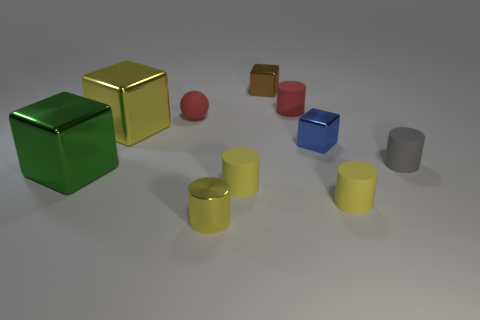The tiny rubber thing that is the same color as the rubber ball is what shape?
Offer a terse response. Cylinder. How big is the yellow thing left of the tiny red rubber object that is on the left side of the brown object?
Your answer should be very brief. Large. There is a small shiny cylinder; is it the same color as the matte cylinder to the left of the tiny brown thing?
Offer a very short reply. Yes. Is the number of metallic things in front of the tiny metal cylinder less than the number of small yellow objects?
Make the answer very short. Yes. What number of other objects are there of the same size as the green metallic cube?
Your response must be concise. 1. Is the shape of the large thing in front of the big yellow metallic object the same as  the small blue object?
Make the answer very short. Yes. Is the number of large cubes that are on the right side of the green thing greater than the number of small green metal spheres?
Your answer should be very brief. Yes. What material is the object that is right of the small blue cube and in front of the green object?
Ensure brevity in your answer.  Rubber. How many cubes are on the right side of the small yellow metal thing and in front of the yellow shiny block?
Make the answer very short. 1. What is the material of the green thing?
Keep it short and to the point. Metal. 